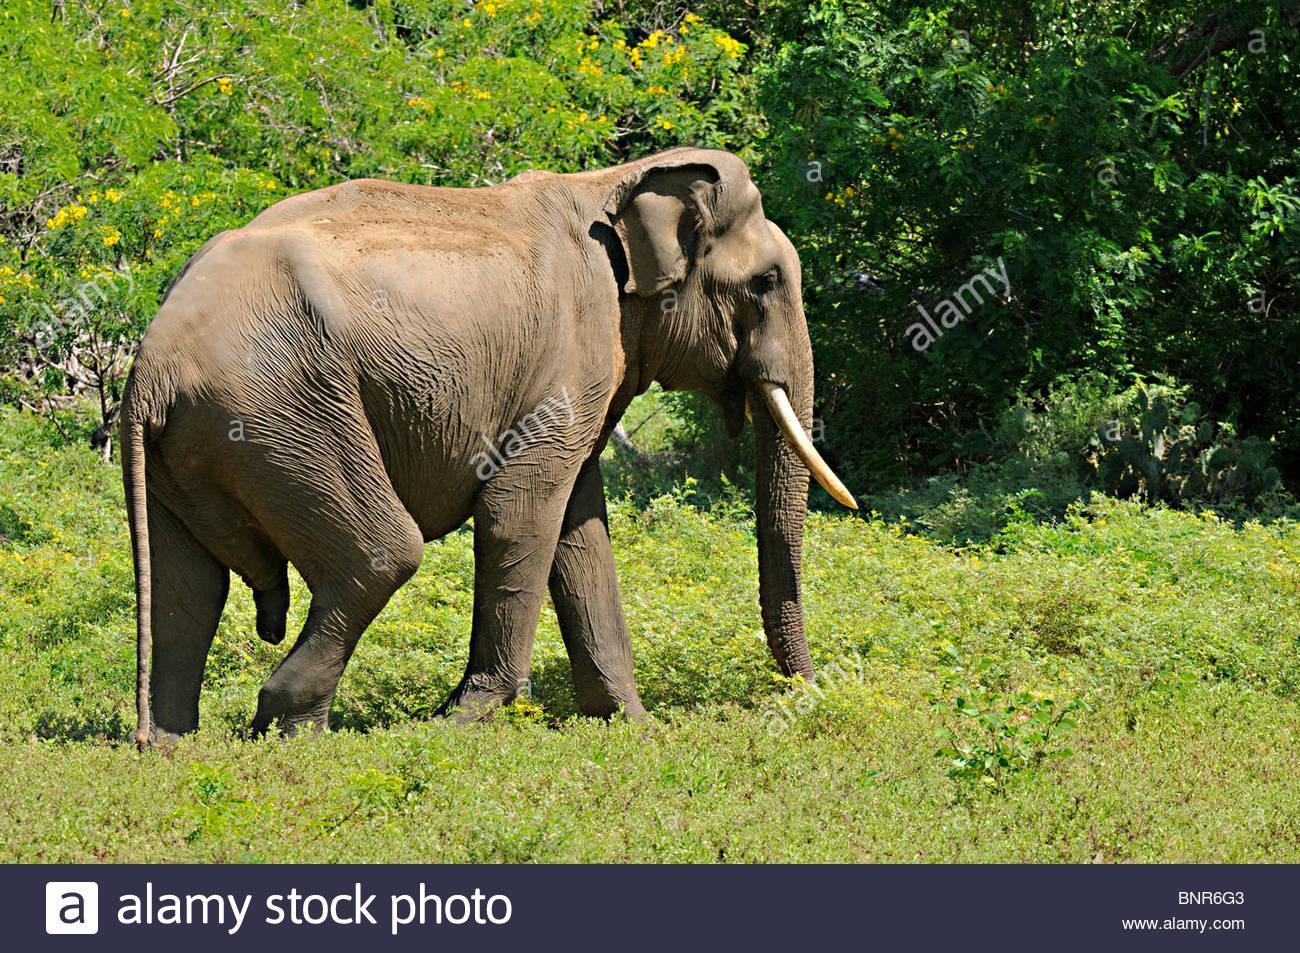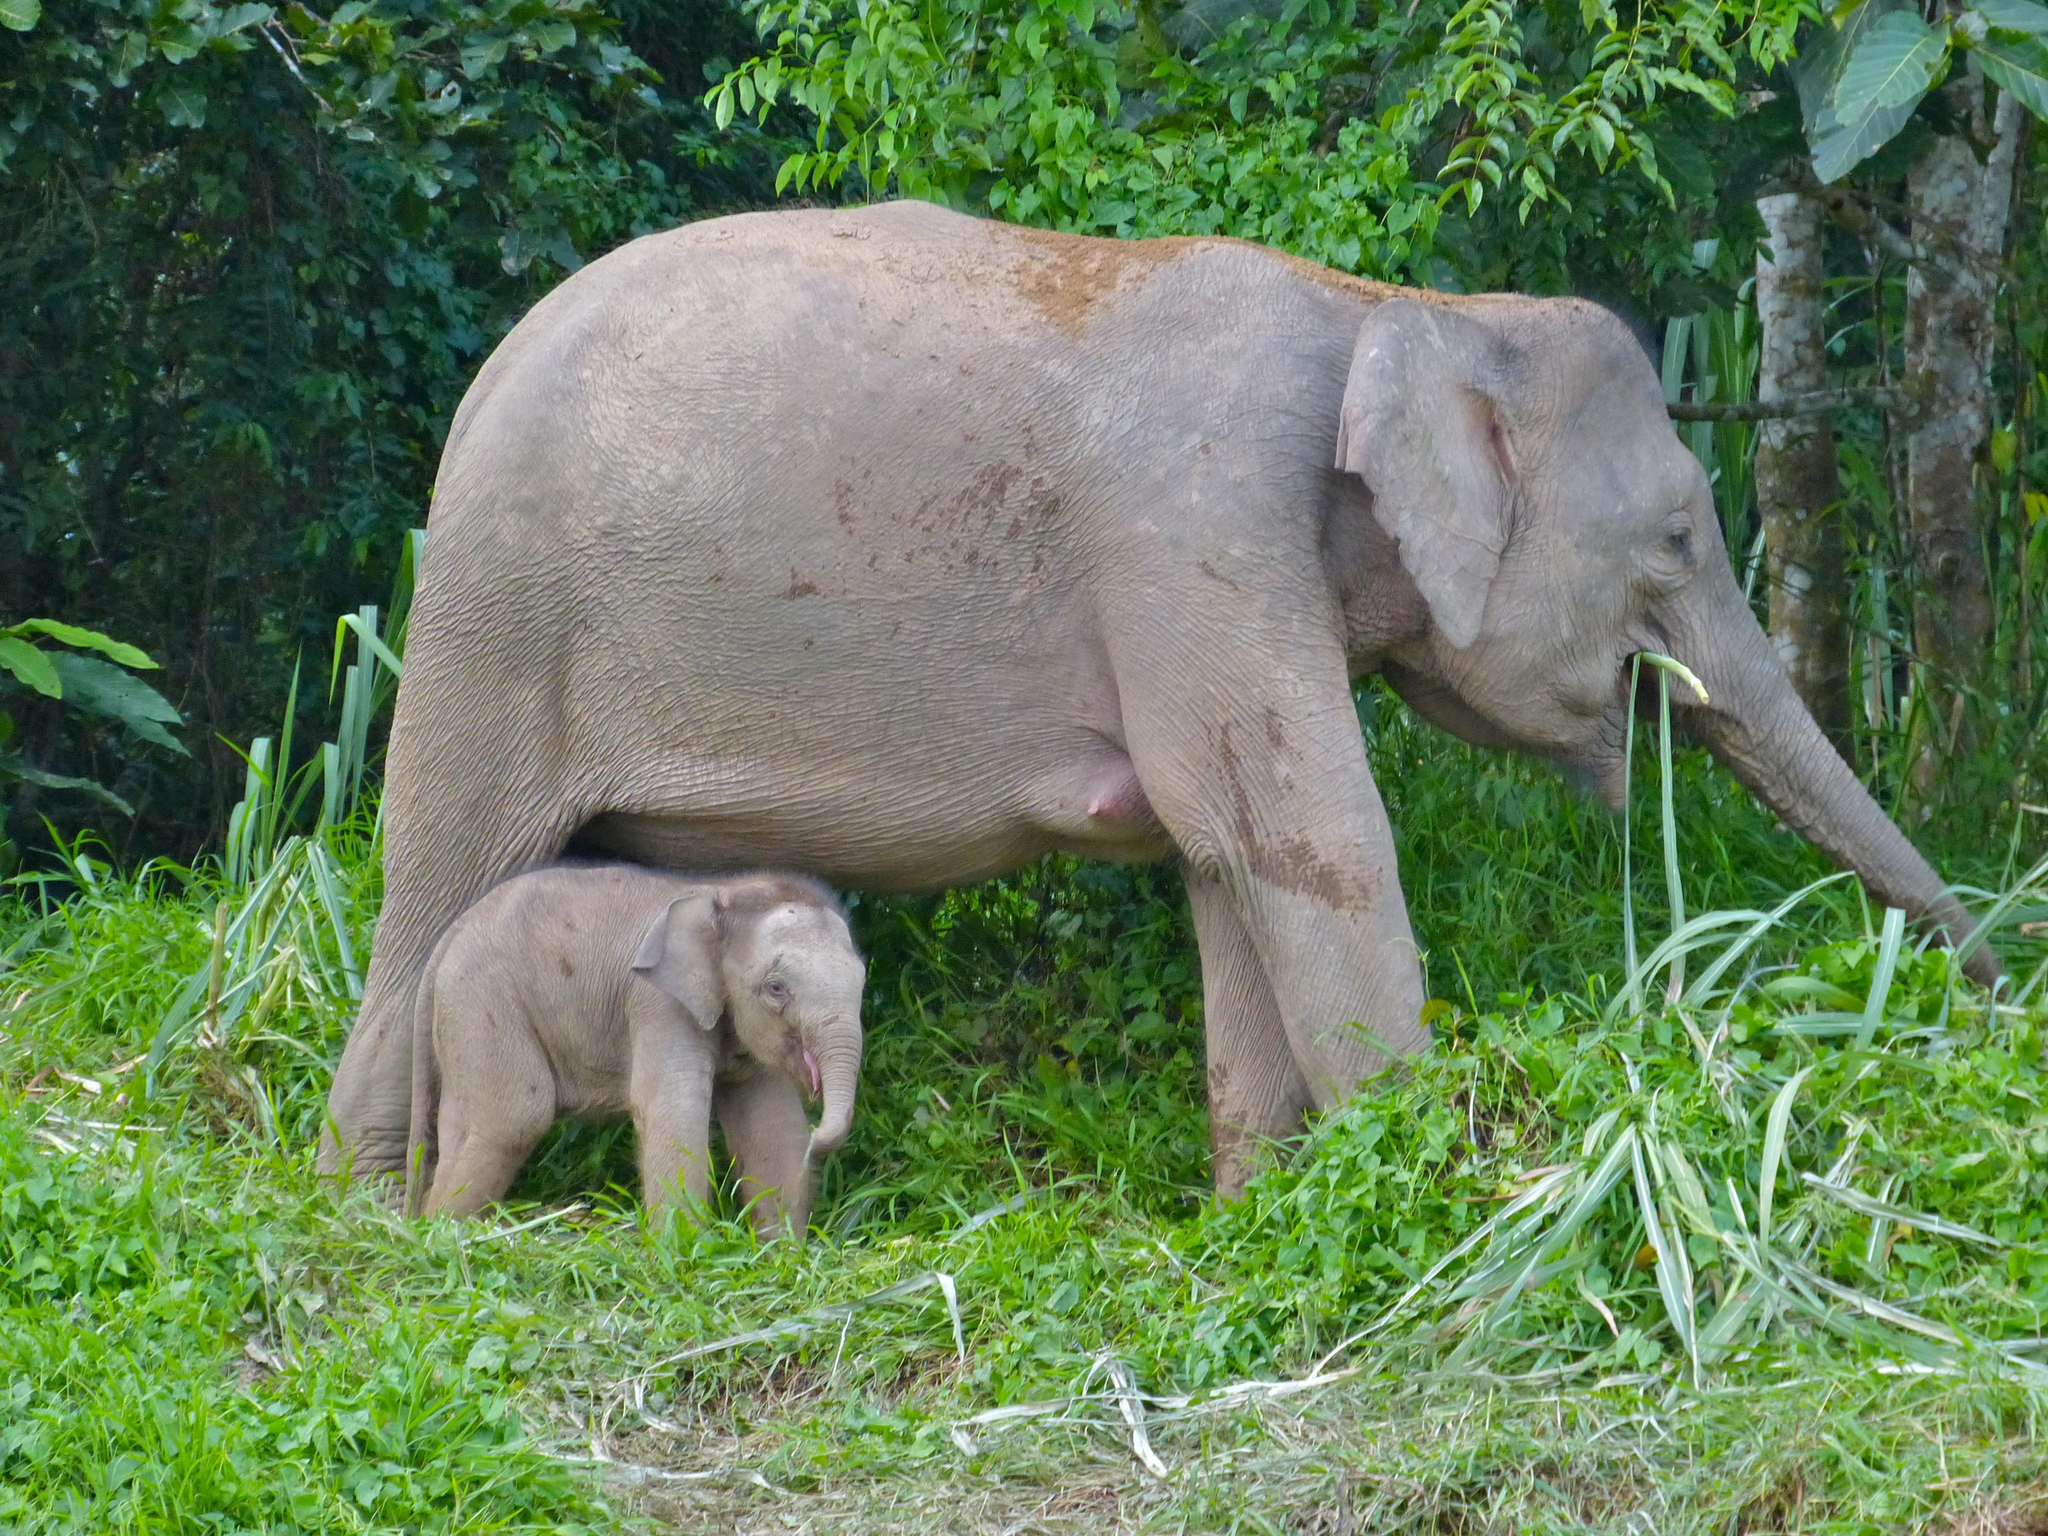The first image is the image on the left, the second image is the image on the right. For the images shown, is this caption "There is one tusked animal in the grass in the image on the left." true? Answer yes or no. Yes. The first image is the image on the left, the second image is the image on the right. For the images shown, is this caption "An image features just one elephant, which has large tusks." true? Answer yes or no. Yes. 